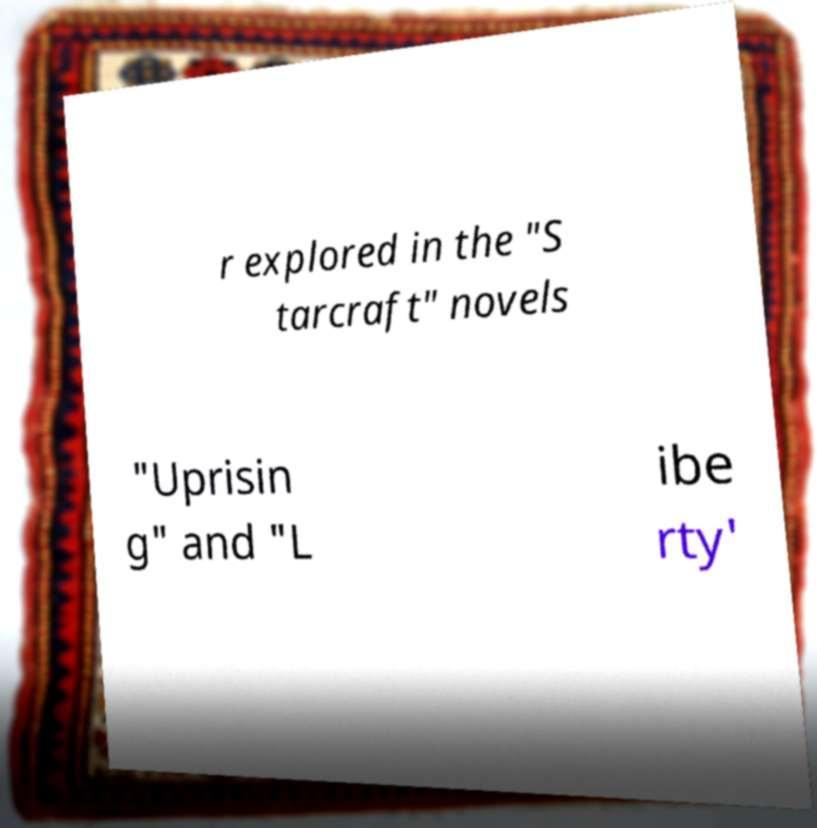Can you read and provide the text displayed in the image?This photo seems to have some interesting text. Can you extract and type it out for me? r explored in the "S tarcraft" novels "Uprisin g" and "L ibe rty' 